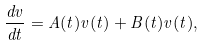<formula> <loc_0><loc_0><loc_500><loc_500>\frac { d v } { d t } = A ( t ) v ( t ) + B ( t ) v ( t ) ,</formula> 